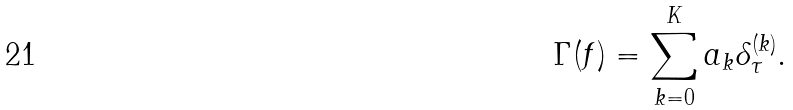Convert formula to latex. <formula><loc_0><loc_0><loc_500><loc_500>\Gamma ( f ) = \sum _ { k = 0 } ^ { K } a _ { k } \delta _ { \tau } ^ { ( k ) } .</formula> 